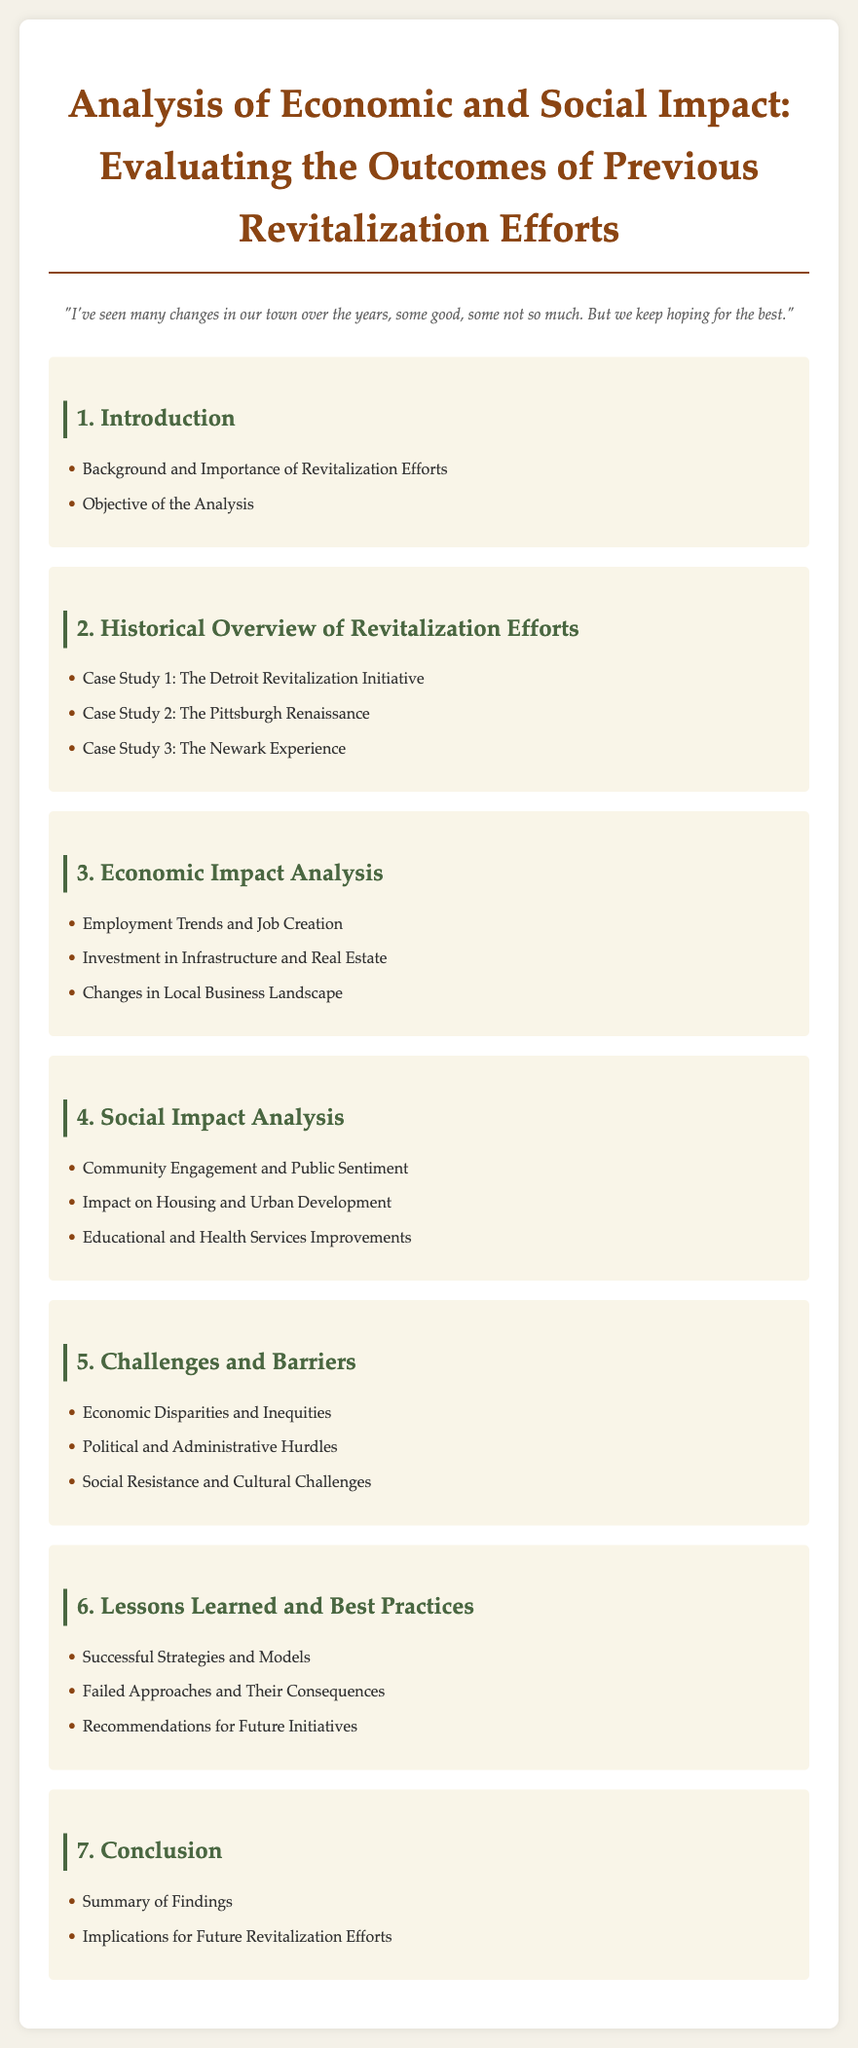What is the title of the document? The title is stated prominently at the top of the document as "Analysis of Economic and Social Impact: Evaluating the Outcomes of Previous Revitalization Efforts."
Answer: Analysis of Economic and Social Impact: Evaluating the Outcomes of Previous Revitalization Efforts How many case studies are mentioned in the historical overview? The document lists three case studies under the Historical Overview of Revitalization Efforts.
Answer: 3 What is one of the areas of economic impact analyzed? The document specifies "Employment Trends and Job Creation" as one area of economic impact analyzed.
Answer: Employment Trends and Job Creation Name one of the social impacts analyzed. The section on social impacts includes "Community Engagement and Public Sentiment" as one of the analyzed areas.
Answer: Community Engagement and Public Sentiment What chapter discusses challenges and barriers? The document indicates that chapter 5 covers "Challenges and Barriers."
Answer: Challenges and Barriers What is one key element discussed in lessons learned? "Successful Strategies and Models" is listed as a key element in the lessons learned chapter.
Answer: Successful Strategies and Models How many recommendations are provided for future initiatives? The document mentions that one of the topics in chapter 6 is about "Recommendations for Future Initiatives." The number of recommendations is not specified.
Answer: Recommendations for Future Initiatives 